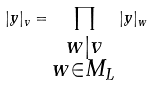<formula> <loc_0><loc_0><loc_500><loc_500>| y | _ { v } = \prod _ { \substack { w | v \\ w \in M _ { L } } } | y | _ { w }</formula> 